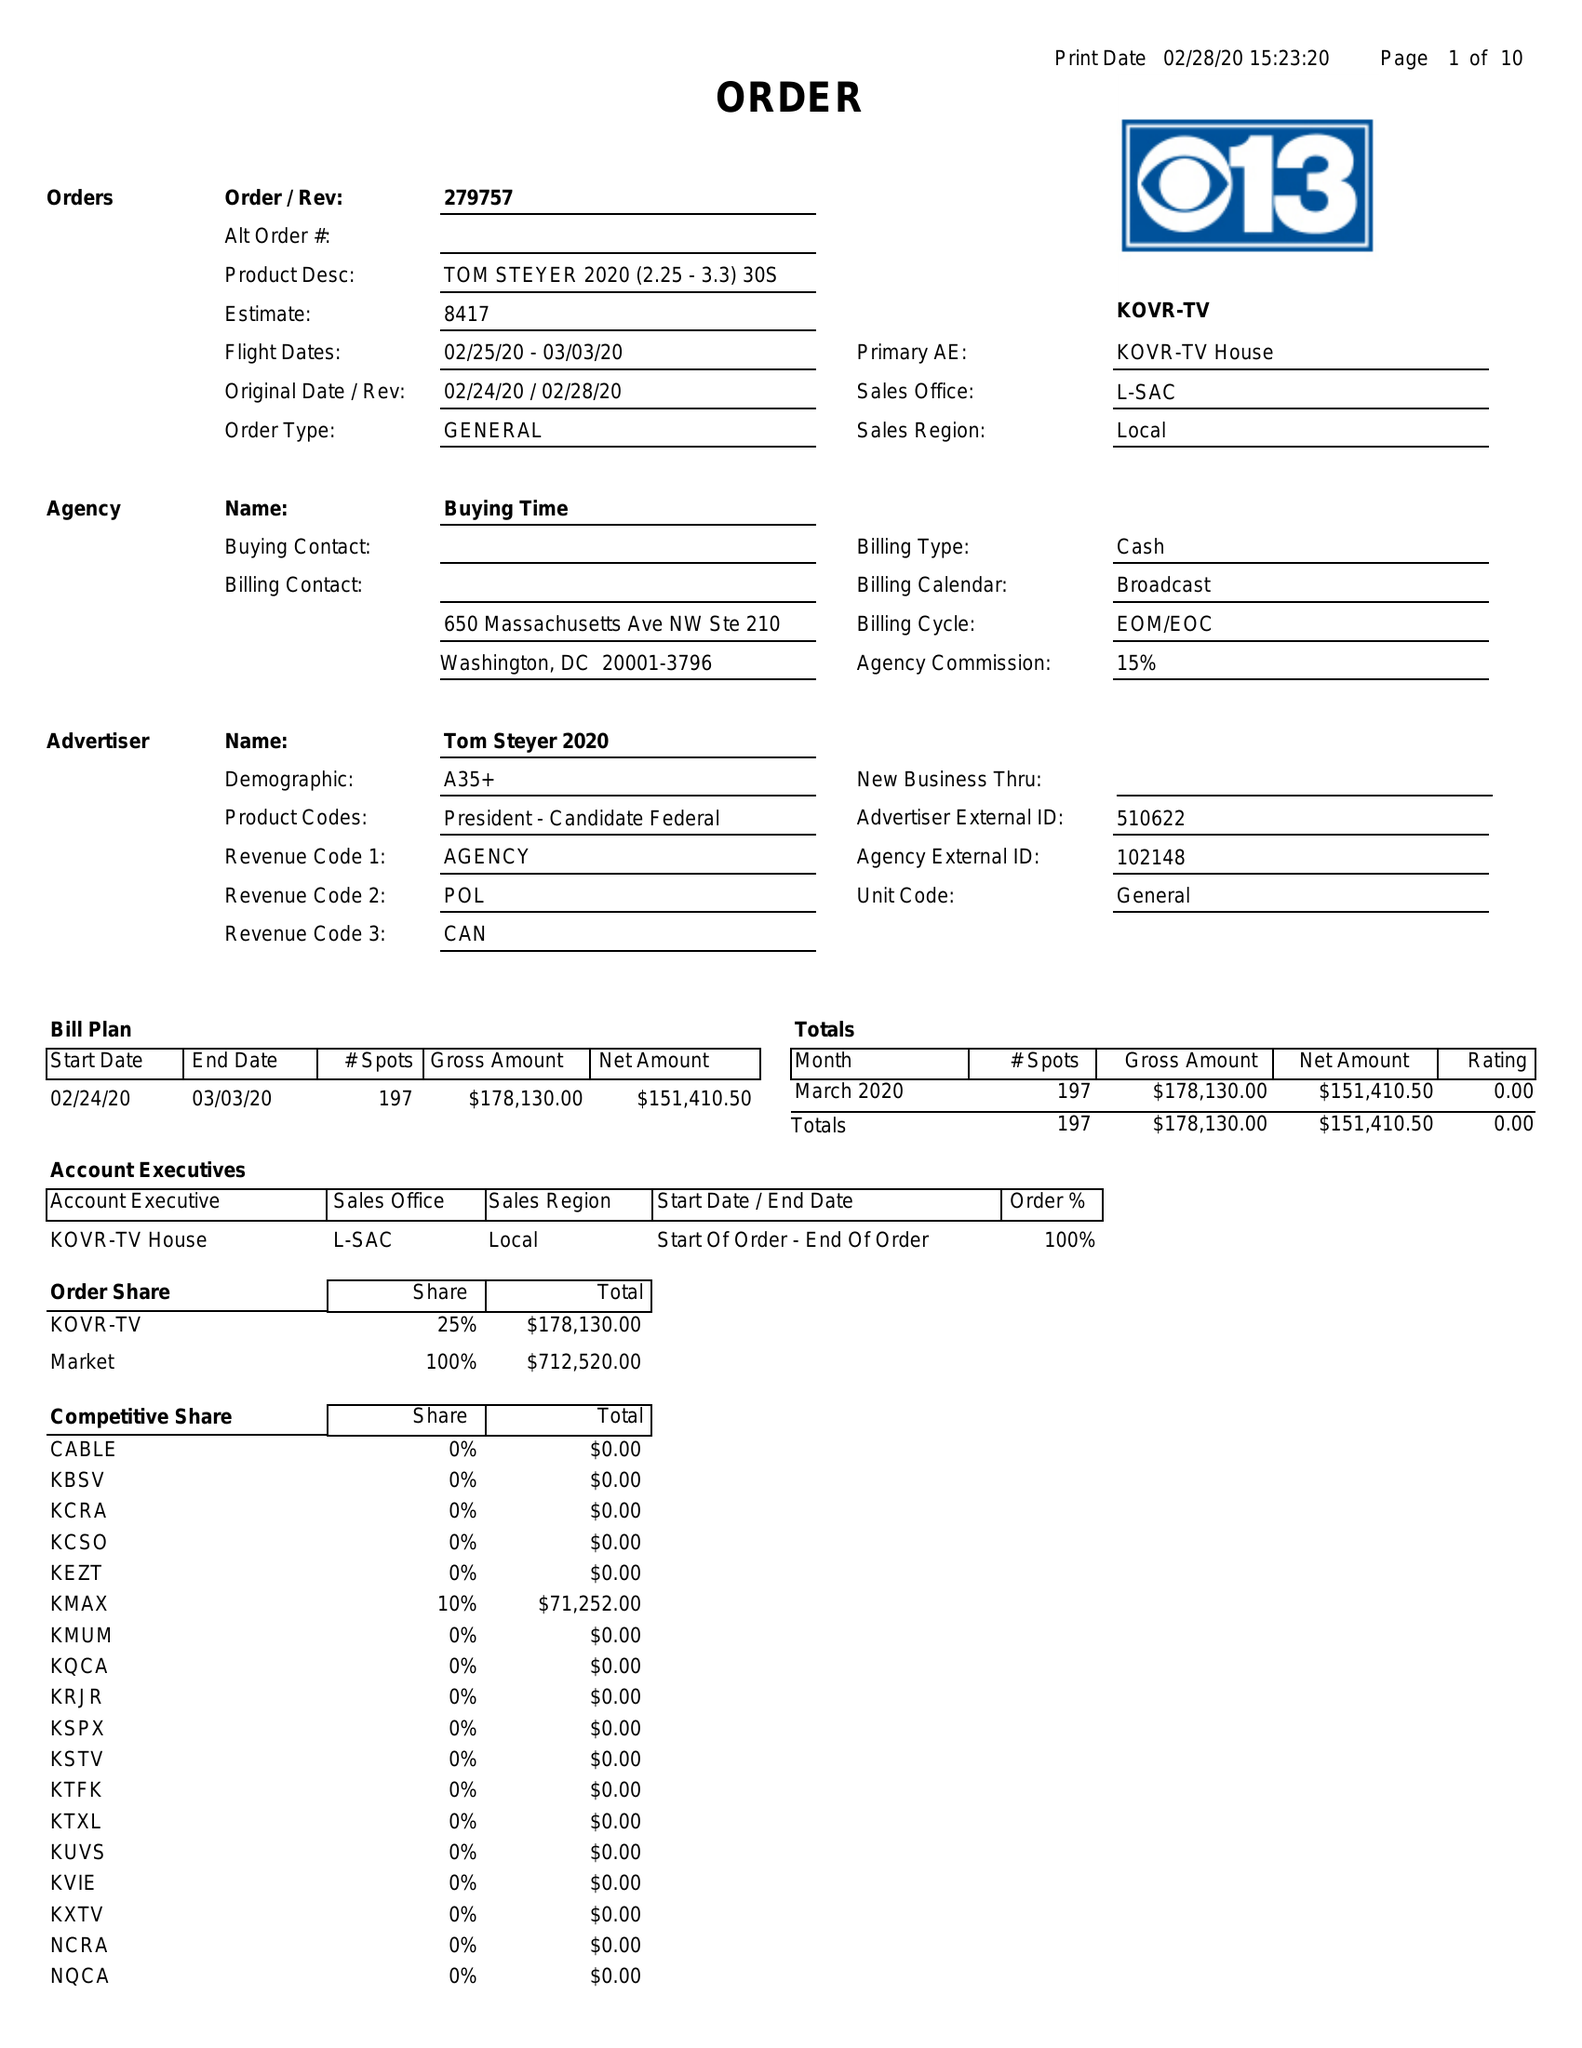What is the value for the flight_to?
Answer the question using a single word or phrase. 03/03/20 